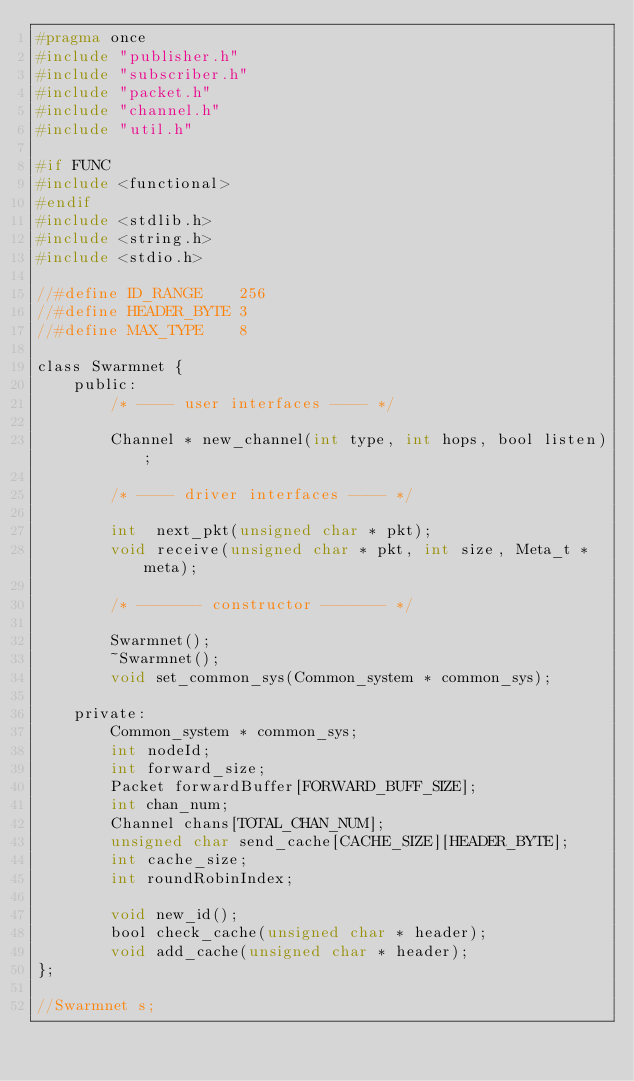Convert code to text. <code><loc_0><loc_0><loc_500><loc_500><_C_>#pragma once
#include "publisher.h"
#include "subscriber.h"
#include "packet.h"
#include "channel.h"
#include "util.h"

#if FUNC
#include <functional>
#endif
#include <stdlib.h>
#include <string.h>
#include <stdio.h>

//#define ID_RANGE    256
//#define HEADER_BYTE 3
//#define MAX_TYPE    8

class Swarmnet {
    public:
        /* ---- user interfaces ---- */

        Channel * new_channel(int type, int hops, bool listen);
        
        /* ---- driver interfaces ---- */   
     
        int  next_pkt(unsigned char * pkt);
        void receive(unsigned char * pkt, int size, Meta_t * meta);

        /* ------- constructor ------- */   

        Swarmnet();
        ~Swarmnet();
        void set_common_sys(Common_system * common_sys);

    private:
        Common_system * common_sys;
        int nodeId;
        int forward_size;
        Packet forwardBuffer[FORWARD_BUFF_SIZE];
        int chan_num;
        Channel chans[TOTAL_CHAN_NUM];
        unsigned char send_cache[CACHE_SIZE][HEADER_BYTE];
        int cache_size;
        int roundRobinIndex;

        void new_id();
        bool check_cache(unsigned char * header);
        void add_cache(unsigned char * header);
};

//Swarmnet s;
</code> 